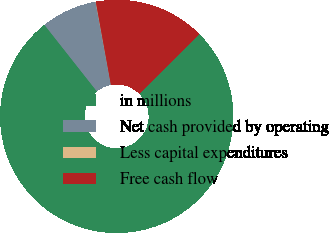<chart> <loc_0><loc_0><loc_500><loc_500><pie_chart><fcel>in millions<fcel>Net cash provided by operating<fcel>Less capital expenditures<fcel>Free cash flow<nl><fcel>76.84%<fcel>7.72%<fcel>0.04%<fcel>15.4%<nl></chart> 